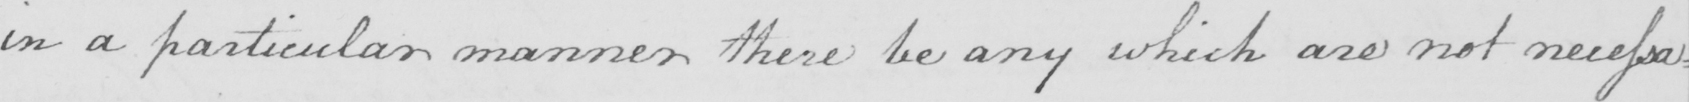Please transcribe the handwritten text in this image. in a particular manner there be any which are not necessa= 